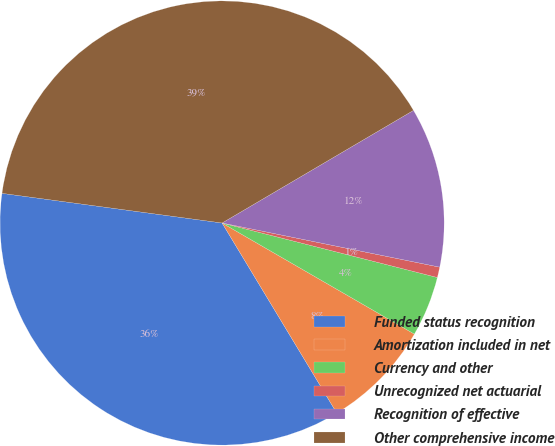Convert chart to OTSL. <chart><loc_0><loc_0><loc_500><loc_500><pie_chart><fcel>Funded status recognition<fcel>Amortization included in net<fcel>Currency and other<fcel>Unrecognized net actuarial<fcel>Recognition of effective<fcel>Other comprehensive income<nl><fcel>35.77%<fcel>8.02%<fcel>4.39%<fcel>0.76%<fcel>11.65%<fcel>39.4%<nl></chart> 